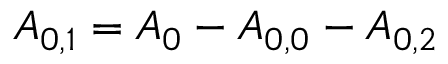Convert formula to latex. <formula><loc_0><loc_0><loc_500><loc_500>{ A _ { 0 , 1 } } = { A _ { 0 } } - { A _ { 0 , 0 } } - { A _ { 0 , 2 } }</formula> 